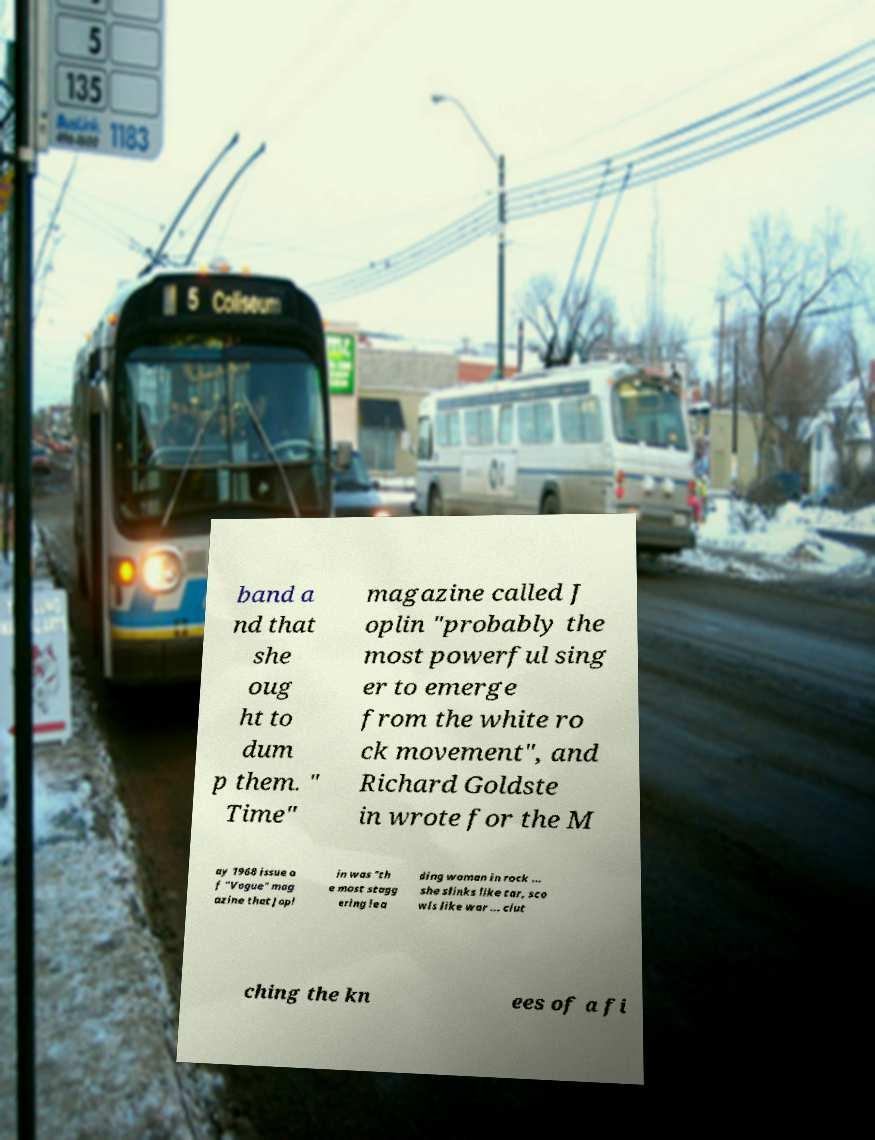There's text embedded in this image that I need extracted. Can you transcribe it verbatim? band a nd that she oug ht to dum p them. " Time" magazine called J oplin "probably the most powerful sing er to emerge from the white ro ck movement", and Richard Goldste in wrote for the M ay 1968 issue o f "Vogue" mag azine that Jopl in was "th e most stagg ering lea ding woman in rock ... she slinks like tar, sco wls like war ... clut ching the kn ees of a fi 